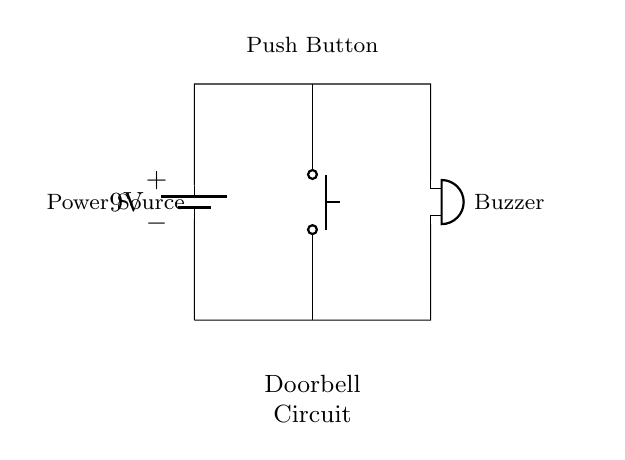what is the voltage of the battery? The circuit diagram shows a 9V battery indicated at the top left corner. This component provides the voltage source for the circuit.
Answer: 9V what type of switch is used in the circuit? The diagram labels the switch as a "push button" located in the center of the circuit. This indicates the type of switch used to activate the buzzer when pressed.
Answer: push button how many components are in this circuit? By counting the components shown in the diagram, there are a total of three distinct parts: a battery, a buzzer, and a push button switch. This count includes all essential elements of the circuit.
Answer: 3 what happens when the push button is pressed? Pressing the push button completes the circuit, allowing current to flow from the battery to the buzzer, which activates it to announce visitors. This functionality is typical for doorbell circuits.
Answer: buzzer sounds what is the purpose of the buzzer in this circuit? The buzzer serves as an alert mechanism, producing sound to inform the homeowner that someone is at the door when the push button is activated. This is the main function of the buzzer in the doorbell circuit.
Answer: sound alert is the circuit series or parallel? The circuit can be classified as a series circuit since the components are connected end-to-end: the battery, push button, and buzzer are in sequence. In this type of connection, the same current flows through all components.
Answer: series 